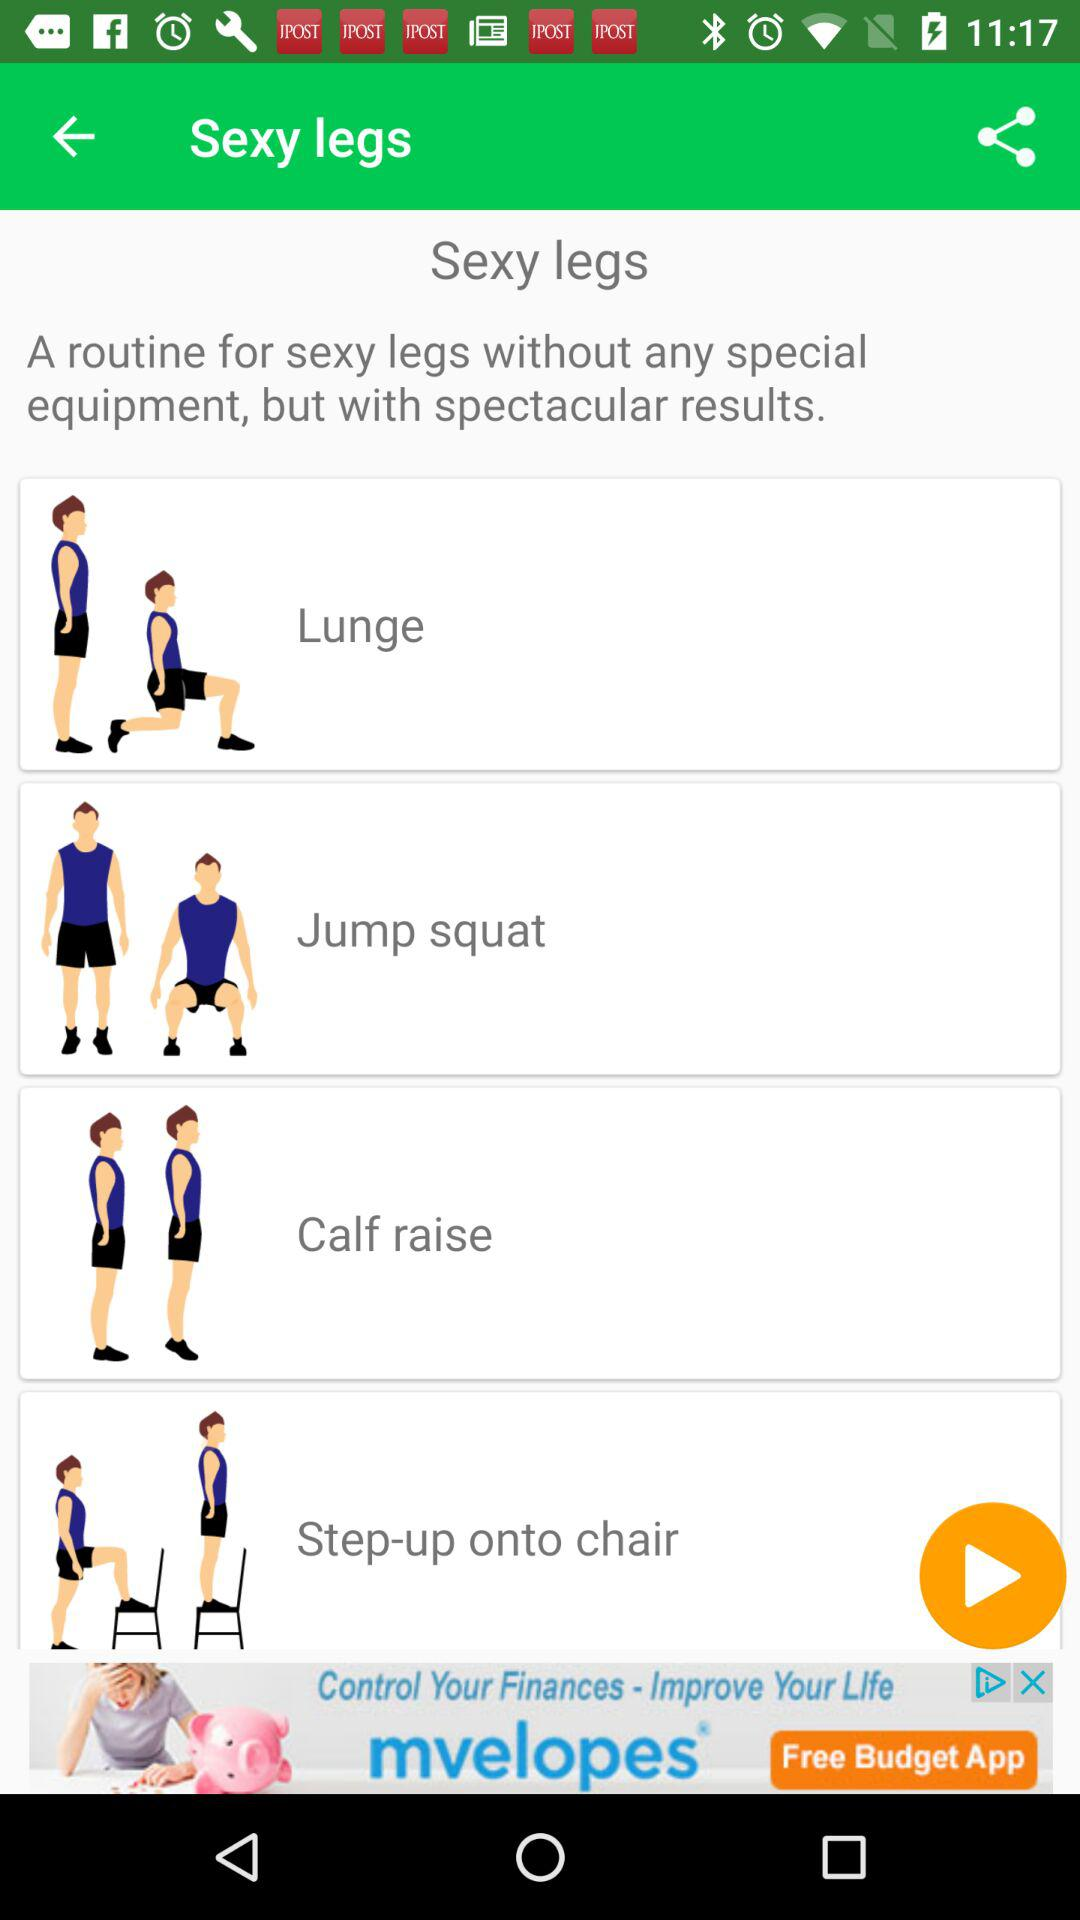How many exercises are there in this workout?
Answer the question using a single word or phrase. 4 